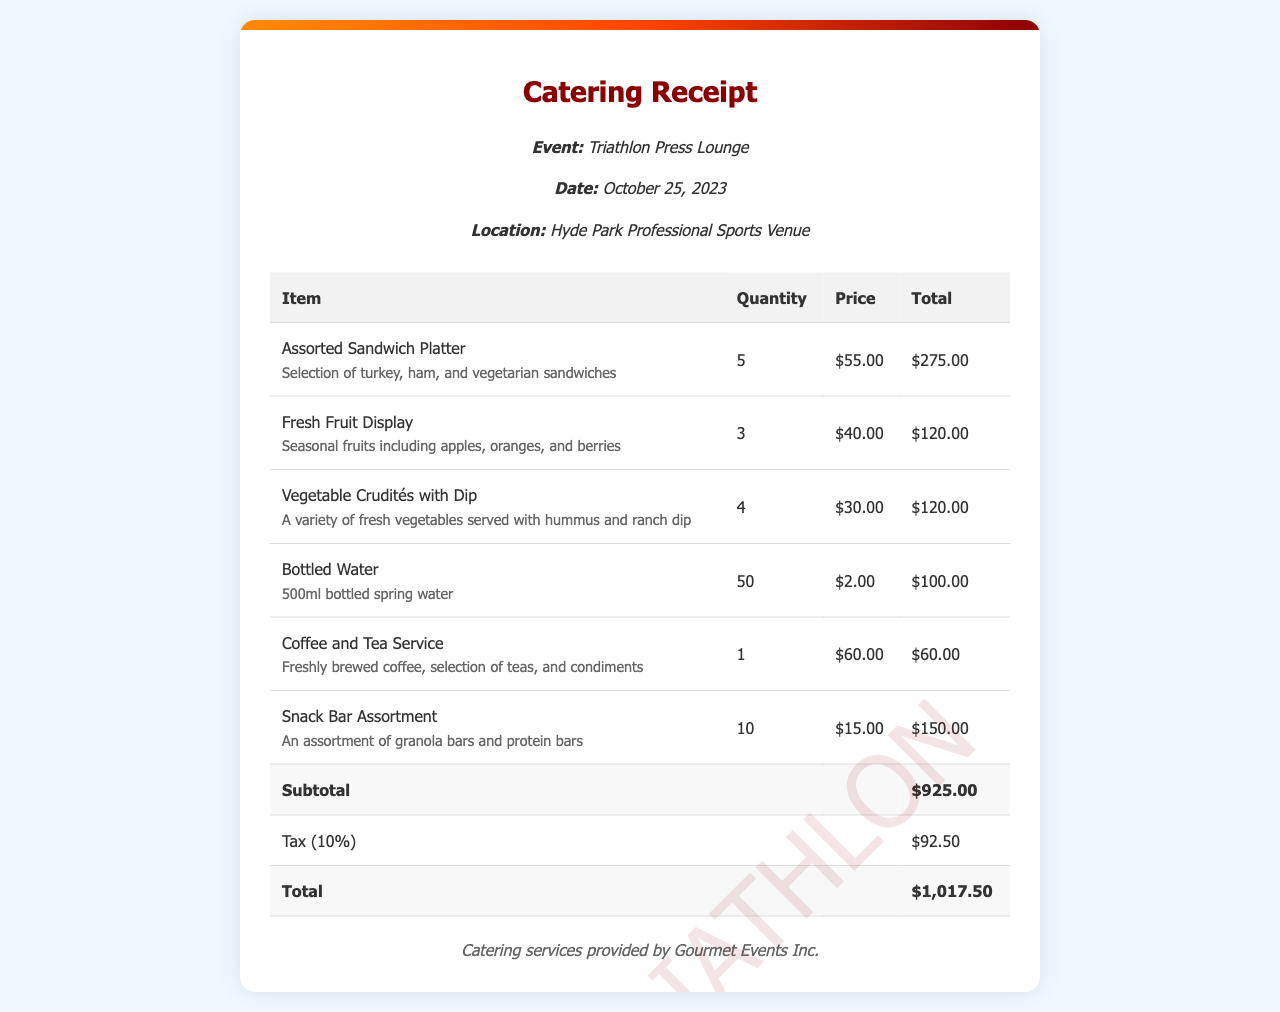What is the total cost of the Assorted Sandwich Platter? The total cost is calculated by multiplying the quantity (5) by the price per item ($55.00), which equals $275.00.
Answer: $275.00 How many Bottled Water were ordered? The document states a quantity of 50 for Bottled Water.
Answer: 50 What is the subtotal amount before tax? The subtotal is the sum of all item totals, which amounts to $925.00.
Answer: $925.00 What is the tax rate applied to the catering bill? The document specifies a tax of 10% on the subtotal.
Answer: 10% What type of catering service was provided? The notes mention that catering services were provided by Gourmet Events Inc.
Answer: Gourmet Events Inc What is the total amount after including tax? The total is the sum of the subtotal ($925.00) and the tax ($92.50), resulting in $1,017.50.
Answer: $1,017.50 How many different food items were listed in the receipt? There are 6 different food items listed in the document.
Answer: 6 What does the Fresh Fruit Display include? The description mentions seasonal fruits including apples, oranges, and berries.
Answer: apples, oranges, and berries What was the date of the event? The event date noted in the document is October 25, 2023.
Answer: October 25, 2023 